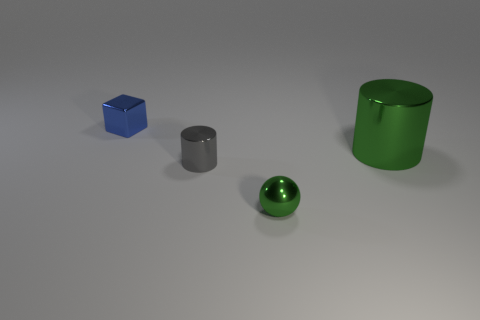What number of matte things are either small blue blocks or green things? In the image, we observe one small blue block and two green items, which are a sphere and a cylinder. Therefore, the total number of matte items that are either small blue blocks or green things is three. 